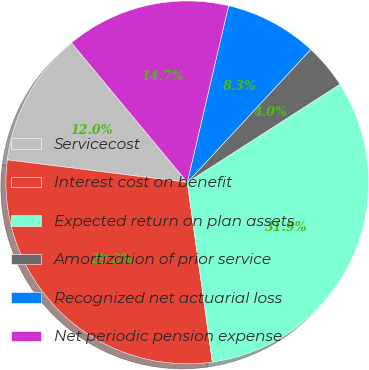Convert chart to OTSL. <chart><loc_0><loc_0><loc_500><loc_500><pie_chart><fcel>Servicecost<fcel>Interest cost on benefit<fcel>Expected return on plan assets<fcel>Amortization of prior service<fcel>Recognized net actuarial loss<fcel>Net periodic pension expense<nl><fcel>11.99%<fcel>29.19%<fcel>31.89%<fcel>4.0%<fcel>8.26%<fcel>14.68%<nl></chart> 